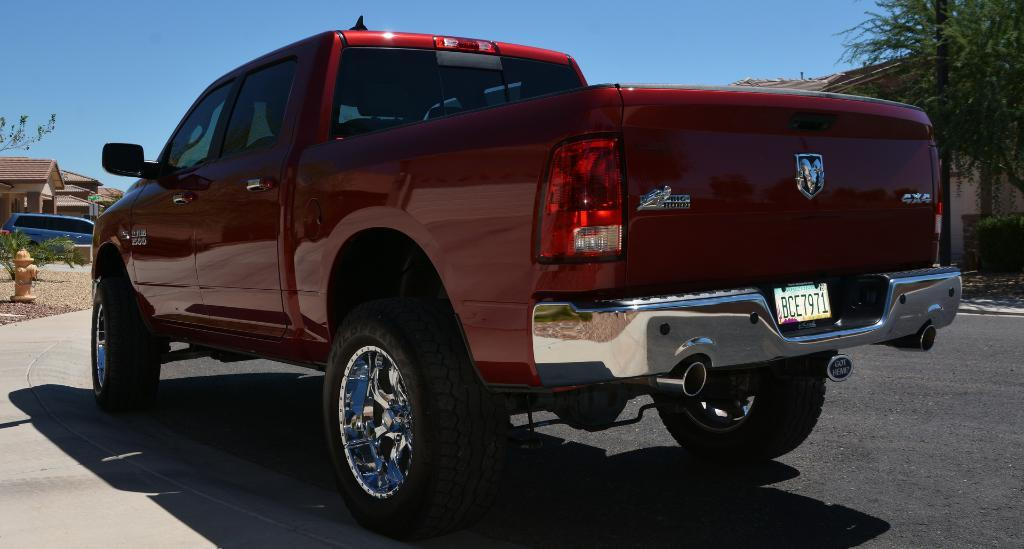What is the main subject of the image? There is a vehicle on the road in the image. What else can be seen in the image besides the vehicle? There are houses and trees visible in the image. Can you describe any specific features of the road in the image? There is a fire hydrant to the side of the road in the image. What type of voice can be heard coming from the observation tower in the image? There is no observation tower present in the image, so it is not possible to determine what type of voice might be heard. 